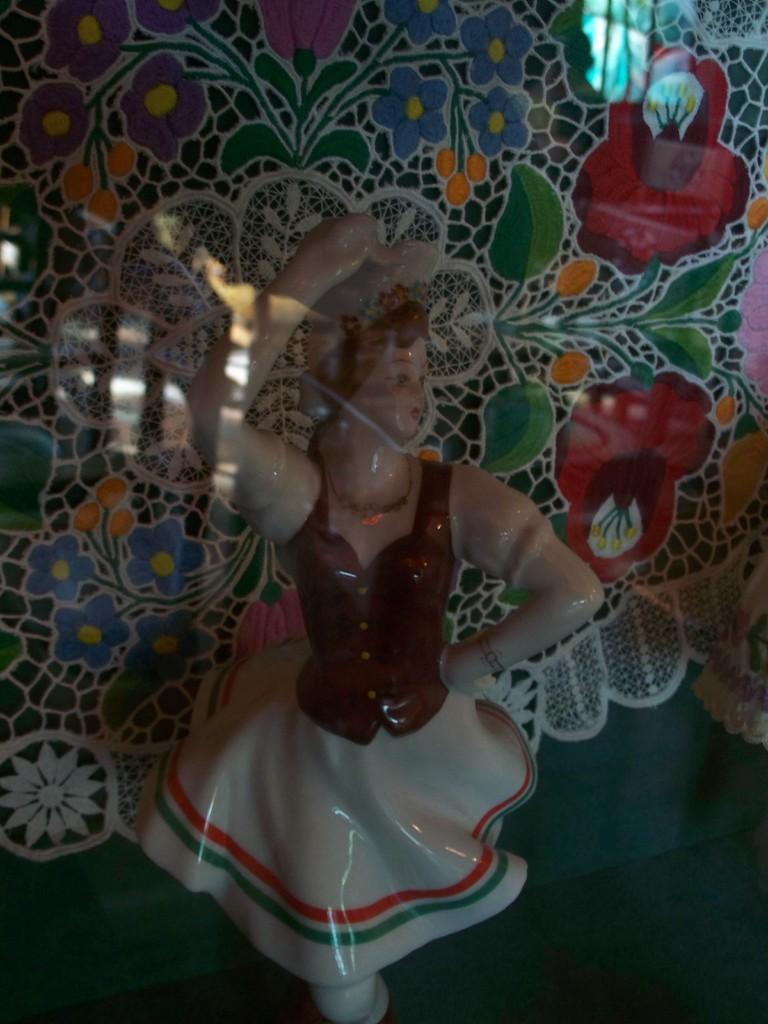What is the main subject in the image? There is a statue in the image. Where is the statue located? The statue is on the ground. What else can be seen in the image besides the statue? There is a cover with a design in the image. How many bubbles are floating around the statue in the image? There are no bubbles present in the image; it only features a statue and a cover with a design. 